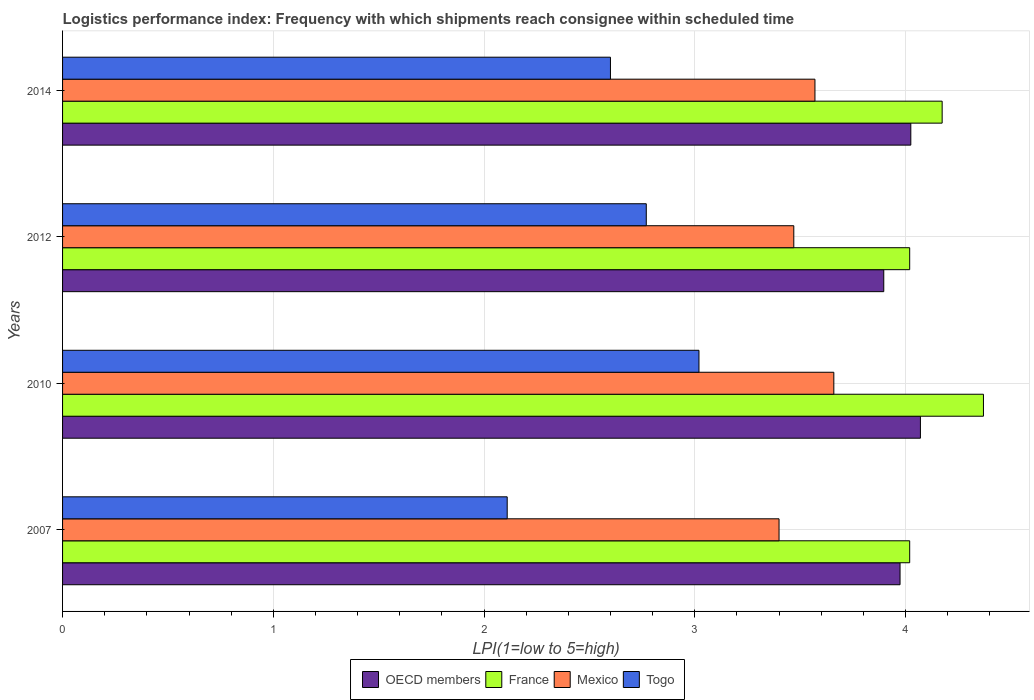How many groups of bars are there?
Your answer should be very brief. 4. Are the number of bars on each tick of the Y-axis equal?
Offer a very short reply. Yes. How many bars are there on the 3rd tick from the top?
Your answer should be very brief. 4. What is the label of the 3rd group of bars from the top?
Give a very brief answer. 2010. In how many cases, is the number of bars for a given year not equal to the number of legend labels?
Your answer should be compact. 0. What is the logistics performance index in France in 2007?
Keep it short and to the point. 4.02. Across all years, what is the maximum logistics performance index in OECD members?
Make the answer very short. 4.07. Across all years, what is the minimum logistics performance index in France?
Your response must be concise. 4.02. In which year was the logistics performance index in France maximum?
Offer a terse response. 2010. What is the total logistics performance index in Togo in the graph?
Offer a very short reply. 10.5. What is the difference between the logistics performance index in OECD members in 2010 and that in 2014?
Your answer should be compact. 0.05. What is the difference between the logistics performance index in France in 2014 and the logistics performance index in OECD members in 2007?
Your answer should be very brief. 0.2. What is the average logistics performance index in Mexico per year?
Offer a very short reply. 3.53. In the year 2012, what is the difference between the logistics performance index in OECD members and logistics performance index in France?
Keep it short and to the point. -0.12. In how many years, is the logistics performance index in Togo greater than 2 ?
Keep it short and to the point. 4. What is the ratio of the logistics performance index in Mexico in 2012 to that in 2014?
Your answer should be compact. 0.97. Is the logistics performance index in France in 2010 less than that in 2014?
Ensure brevity in your answer.  No. What is the difference between the highest and the second highest logistics performance index in Mexico?
Offer a very short reply. 0.09. What is the difference between the highest and the lowest logistics performance index in OECD members?
Give a very brief answer. 0.17. In how many years, is the logistics performance index in France greater than the average logistics performance index in France taken over all years?
Your response must be concise. 2. Is the sum of the logistics performance index in France in 2012 and 2014 greater than the maximum logistics performance index in Mexico across all years?
Keep it short and to the point. Yes. Is it the case that in every year, the sum of the logistics performance index in France and logistics performance index in Togo is greater than the sum of logistics performance index in Mexico and logistics performance index in OECD members?
Keep it short and to the point. No. What does the 2nd bar from the top in 2012 represents?
Keep it short and to the point. Mexico. What does the 3rd bar from the bottom in 2007 represents?
Offer a terse response. Mexico. Is it the case that in every year, the sum of the logistics performance index in OECD members and logistics performance index in France is greater than the logistics performance index in Mexico?
Make the answer very short. Yes. How many bars are there?
Give a very brief answer. 16. Are the values on the major ticks of X-axis written in scientific E-notation?
Your answer should be very brief. No. Where does the legend appear in the graph?
Your response must be concise. Bottom center. How many legend labels are there?
Your answer should be compact. 4. How are the legend labels stacked?
Provide a short and direct response. Horizontal. What is the title of the graph?
Offer a very short reply. Logistics performance index: Frequency with which shipments reach consignee within scheduled time. What is the label or title of the X-axis?
Make the answer very short. LPI(1=low to 5=high). What is the LPI(1=low to 5=high) in OECD members in 2007?
Make the answer very short. 3.97. What is the LPI(1=low to 5=high) of France in 2007?
Provide a short and direct response. 4.02. What is the LPI(1=low to 5=high) of Mexico in 2007?
Your answer should be compact. 3.4. What is the LPI(1=low to 5=high) in Togo in 2007?
Keep it short and to the point. 2.11. What is the LPI(1=low to 5=high) of OECD members in 2010?
Provide a short and direct response. 4.07. What is the LPI(1=low to 5=high) in France in 2010?
Your response must be concise. 4.37. What is the LPI(1=low to 5=high) of Mexico in 2010?
Give a very brief answer. 3.66. What is the LPI(1=low to 5=high) in Togo in 2010?
Provide a succinct answer. 3.02. What is the LPI(1=low to 5=high) in OECD members in 2012?
Ensure brevity in your answer.  3.9. What is the LPI(1=low to 5=high) in France in 2012?
Give a very brief answer. 4.02. What is the LPI(1=low to 5=high) in Mexico in 2012?
Make the answer very short. 3.47. What is the LPI(1=low to 5=high) in Togo in 2012?
Keep it short and to the point. 2.77. What is the LPI(1=low to 5=high) in OECD members in 2014?
Provide a short and direct response. 4.03. What is the LPI(1=low to 5=high) of France in 2014?
Your response must be concise. 4.17. What is the LPI(1=low to 5=high) of Mexico in 2014?
Give a very brief answer. 3.57. What is the LPI(1=low to 5=high) of Togo in 2014?
Your answer should be compact. 2.6. Across all years, what is the maximum LPI(1=low to 5=high) of OECD members?
Your answer should be very brief. 4.07. Across all years, what is the maximum LPI(1=low to 5=high) of France?
Give a very brief answer. 4.37. Across all years, what is the maximum LPI(1=low to 5=high) of Mexico?
Make the answer very short. 3.66. Across all years, what is the maximum LPI(1=low to 5=high) of Togo?
Offer a terse response. 3.02. Across all years, what is the minimum LPI(1=low to 5=high) in OECD members?
Offer a very short reply. 3.9. Across all years, what is the minimum LPI(1=low to 5=high) in France?
Give a very brief answer. 4.02. Across all years, what is the minimum LPI(1=low to 5=high) in Mexico?
Ensure brevity in your answer.  3.4. Across all years, what is the minimum LPI(1=low to 5=high) of Togo?
Give a very brief answer. 2.11. What is the total LPI(1=low to 5=high) of OECD members in the graph?
Provide a succinct answer. 15.97. What is the total LPI(1=low to 5=high) in France in the graph?
Provide a succinct answer. 16.58. What is the total LPI(1=low to 5=high) of Mexico in the graph?
Offer a very short reply. 14.1. What is the difference between the LPI(1=low to 5=high) of OECD members in 2007 and that in 2010?
Provide a succinct answer. -0.1. What is the difference between the LPI(1=low to 5=high) of France in 2007 and that in 2010?
Offer a terse response. -0.35. What is the difference between the LPI(1=low to 5=high) in Mexico in 2007 and that in 2010?
Your response must be concise. -0.26. What is the difference between the LPI(1=low to 5=high) of Togo in 2007 and that in 2010?
Make the answer very short. -0.91. What is the difference between the LPI(1=low to 5=high) in OECD members in 2007 and that in 2012?
Your response must be concise. 0.08. What is the difference between the LPI(1=low to 5=high) of France in 2007 and that in 2012?
Make the answer very short. 0. What is the difference between the LPI(1=low to 5=high) of Mexico in 2007 and that in 2012?
Your answer should be compact. -0.07. What is the difference between the LPI(1=low to 5=high) in Togo in 2007 and that in 2012?
Keep it short and to the point. -0.66. What is the difference between the LPI(1=low to 5=high) of OECD members in 2007 and that in 2014?
Provide a short and direct response. -0.05. What is the difference between the LPI(1=low to 5=high) in France in 2007 and that in 2014?
Offer a terse response. -0.15. What is the difference between the LPI(1=low to 5=high) of Mexico in 2007 and that in 2014?
Your answer should be compact. -0.17. What is the difference between the LPI(1=low to 5=high) in Togo in 2007 and that in 2014?
Give a very brief answer. -0.49. What is the difference between the LPI(1=low to 5=high) of OECD members in 2010 and that in 2012?
Your response must be concise. 0.17. What is the difference between the LPI(1=low to 5=high) of Mexico in 2010 and that in 2012?
Your answer should be very brief. 0.19. What is the difference between the LPI(1=low to 5=high) of Togo in 2010 and that in 2012?
Offer a very short reply. 0.25. What is the difference between the LPI(1=low to 5=high) in OECD members in 2010 and that in 2014?
Offer a very short reply. 0.05. What is the difference between the LPI(1=low to 5=high) of France in 2010 and that in 2014?
Your answer should be very brief. 0.2. What is the difference between the LPI(1=low to 5=high) of Mexico in 2010 and that in 2014?
Offer a terse response. 0.09. What is the difference between the LPI(1=low to 5=high) of Togo in 2010 and that in 2014?
Provide a succinct answer. 0.42. What is the difference between the LPI(1=low to 5=high) in OECD members in 2012 and that in 2014?
Make the answer very short. -0.13. What is the difference between the LPI(1=low to 5=high) in France in 2012 and that in 2014?
Give a very brief answer. -0.15. What is the difference between the LPI(1=low to 5=high) in Mexico in 2012 and that in 2014?
Keep it short and to the point. -0.1. What is the difference between the LPI(1=low to 5=high) in Togo in 2012 and that in 2014?
Make the answer very short. 0.17. What is the difference between the LPI(1=low to 5=high) in OECD members in 2007 and the LPI(1=low to 5=high) in France in 2010?
Offer a very short reply. -0.4. What is the difference between the LPI(1=low to 5=high) of OECD members in 2007 and the LPI(1=low to 5=high) of Mexico in 2010?
Ensure brevity in your answer.  0.31. What is the difference between the LPI(1=low to 5=high) of OECD members in 2007 and the LPI(1=low to 5=high) of Togo in 2010?
Your response must be concise. 0.95. What is the difference between the LPI(1=low to 5=high) in France in 2007 and the LPI(1=low to 5=high) in Mexico in 2010?
Give a very brief answer. 0.36. What is the difference between the LPI(1=low to 5=high) in France in 2007 and the LPI(1=low to 5=high) in Togo in 2010?
Offer a very short reply. 1. What is the difference between the LPI(1=low to 5=high) in Mexico in 2007 and the LPI(1=low to 5=high) in Togo in 2010?
Offer a very short reply. 0.38. What is the difference between the LPI(1=low to 5=high) in OECD members in 2007 and the LPI(1=low to 5=high) in France in 2012?
Your response must be concise. -0.05. What is the difference between the LPI(1=low to 5=high) of OECD members in 2007 and the LPI(1=low to 5=high) of Mexico in 2012?
Your answer should be very brief. 0.5. What is the difference between the LPI(1=low to 5=high) in OECD members in 2007 and the LPI(1=low to 5=high) in Togo in 2012?
Ensure brevity in your answer.  1.2. What is the difference between the LPI(1=low to 5=high) in France in 2007 and the LPI(1=low to 5=high) in Mexico in 2012?
Provide a short and direct response. 0.55. What is the difference between the LPI(1=low to 5=high) in Mexico in 2007 and the LPI(1=low to 5=high) in Togo in 2012?
Your response must be concise. 0.63. What is the difference between the LPI(1=low to 5=high) in OECD members in 2007 and the LPI(1=low to 5=high) in France in 2014?
Your answer should be compact. -0.2. What is the difference between the LPI(1=low to 5=high) of OECD members in 2007 and the LPI(1=low to 5=high) of Mexico in 2014?
Provide a short and direct response. 0.4. What is the difference between the LPI(1=low to 5=high) of OECD members in 2007 and the LPI(1=low to 5=high) of Togo in 2014?
Your answer should be compact. 1.37. What is the difference between the LPI(1=low to 5=high) in France in 2007 and the LPI(1=low to 5=high) in Mexico in 2014?
Give a very brief answer. 0.45. What is the difference between the LPI(1=low to 5=high) in France in 2007 and the LPI(1=low to 5=high) in Togo in 2014?
Offer a very short reply. 1.42. What is the difference between the LPI(1=low to 5=high) of Mexico in 2007 and the LPI(1=low to 5=high) of Togo in 2014?
Make the answer very short. 0.8. What is the difference between the LPI(1=low to 5=high) in OECD members in 2010 and the LPI(1=low to 5=high) in France in 2012?
Give a very brief answer. 0.05. What is the difference between the LPI(1=low to 5=high) in OECD members in 2010 and the LPI(1=low to 5=high) in Mexico in 2012?
Keep it short and to the point. 0.6. What is the difference between the LPI(1=low to 5=high) in OECD members in 2010 and the LPI(1=low to 5=high) in Togo in 2012?
Your answer should be compact. 1.3. What is the difference between the LPI(1=low to 5=high) of France in 2010 and the LPI(1=low to 5=high) of Mexico in 2012?
Offer a terse response. 0.9. What is the difference between the LPI(1=low to 5=high) of France in 2010 and the LPI(1=low to 5=high) of Togo in 2012?
Provide a succinct answer. 1.6. What is the difference between the LPI(1=low to 5=high) of Mexico in 2010 and the LPI(1=low to 5=high) of Togo in 2012?
Keep it short and to the point. 0.89. What is the difference between the LPI(1=low to 5=high) in OECD members in 2010 and the LPI(1=low to 5=high) in France in 2014?
Ensure brevity in your answer.  -0.1. What is the difference between the LPI(1=low to 5=high) of OECD members in 2010 and the LPI(1=low to 5=high) of Mexico in 2014?
Provide a short and direct response. 0.5. What is the difference between the LPI(1=low to 5=high) in OECD members in 2010 and the LPI(1=low to 5=high) in Togo in 2014?
Provide a succinct answer. 1.47. What is the difference between the LPI(1=low to 5=high) of France in 2010 and the LPI(1=low to 5=high) of Mexico in 2014?
Your response must be concise. 0.8. What is the difference between the LPI(1=low to 5=high) of France in 2010 and the LPI(1=low to 5=high) of Togo in 2014?
Keep it short and to the point. 1.77. What is the difference between the LPI(1=low to 5=high) of Mexico in 2010 and the LPI(1=low to 5=high) of Togo in 2014?
Provide a succinct answer. 1.06. What is the difference between the LPI(1=low to 5=high) in OECD members in 2012 and the LPI(1=low to 5=high) in France in 2014?
Your answer should be compact. -0.28. What is the difference between the LPI(1=low to 5=high) of OECD members in 2012 and the LPI(1=low to 5=high) of Mexico in 2014?
Your response must be concise. 0.33. What is the difference between the LPI(1=low to 5=high) of OECD members in 2012 and the LPI(1=low to 5=high) of Togo in 2014?
Offer a terse response. 1.3. What is the difference between the LPI(1=low to 5=high) of France in 2012 and the LPI(1=low to 5=high) of Mexico in 2014?
Provide a succinct answer. 0.45. What is the difference between the LPI(1=low to 5=high) of France in 2012 and the LPI(1=low to 5=high) of Togo in 2014?
Provide a short and direct response. 1.42. What is the difference between the LPI(1=low to 5=high) of Mexico in 2012 and the LPI(1=low to 5=high) of Togo in 2014?
Provide a short and direct response. 0.87. What is the average LPI(1=low to 5=high) in OECD members per year?
Your response must be concise. 3.99. What is the average LPI(1=low to 5=high) in France per year?
Offer a very short reply. 4.15. What is the average LPI(1=low to 5=high) in Mexico per year?
Offer a terse response. 3.53. What is the average LPI(1=low to 5=high) of Togo per year?
Your answer should be very brief. 2.62. In the year 2007, what is the difference between the LPI(1=low to 5=high) of OECD members and LPI(1=low to 5=high) of France?
Ensure brevity in your answer.  -0.05. In the year 2007, what is the difference between the LPI(1=low to 5=high) in OECD members and LPI(1=low to 5=high) in Mexico?
Offer a very short reply. 0.57. In the year 2007, what is the difference between the LPI(1=low to 5=high) in OECD members and LPI(1=low to 5=high) in Togo?
Provide a short and direct response. 1.86. In the year 2007, what is the difference between the LPI(1=low to 5=high) in France and LPI(1=low to 5=high) in Mexico?
Give a very brief answer. 0.62. In the year 2007, what is the difference between the LPI(1=low to 5=high) in France and LPI(1=low to 5=high) in Togo?
Offer a terse response. 1.91. In the year 2007, what is the difference between the LPI(1=low to 5=high) of Mexico and LPI(1=low to 5=high) of Togo?
Your response must be concise. 1.29. In the year 2010, what is the difference between the LPI(1=low to 5=high) of OECD members and LPI(1=low to 5=high) of France?
Your answer should be compact. -0.3. In the year 2010, what is the difference between the LPI(1=low to 5=high) of OECD members and LPI(1=low to 5=high) of Mexico?
Give a very brief answer. 0.41. In the year 2010, what is the difference between the LPI(1=low to 5=high) in OECD members and LPI(1=low to 5=high) in Togo?
Give a very brief answer. 1.05. In the year 2010, what is the difference between the LPI(1=low to 5=high) in France and LPI(1=low to 5=high) in Mexico?
Offer a very short reply. 0.71. In the year 2010, what is the difference between the LPI(1=low to 5=high) of France and LPI(1=low to 5=high) of Togo?
Provide a succinct answer. 1.35. In the year 2010, what is the difference between the LPI(1=low to 5=high) of Mexico and LPI(1=low to 5=high) of Togo?
Offer a terse response. 0.64. In the year 2012, what is the difference between the LPI(1=low to 5=high) of OECD members and LPI(1=low to 5=high) of France?
Your answer should be compact. -0.12. In the year 2012, what is the difference between the LPI(1=low to 5=high) of OECD members and LPI(1=low to 5=high) of Mexico?
Ensure brevity in your answer.  0.43. In the year 2012, what is the difference between the LPI(1=low to 5=high) in OECD members and LPI(1=low to 5=high) in Togo?
Make the answer very short. 1.13. In the year 2012, what is the difference between the LPI(1=low to 5=high) of France and LPI(1=low to 5=high) of Mexico?
Make the answer very short. 0.55. In the year 2012, what is the difference between the LPI(1=low to 5=high) in Mexico and LPI(1=low to 5=high) in Togo?
Provide a succinct answer. 0.7. In the year 2014, what is the difference between the LPI(1=low to 5=high) in OECD members and LPI(1=low to 5=high) in France?
Ensure brevity in your answer.  -0.15. In the year 2014, what is the difference between the LPI(1=low to 5=high) in OECD members and LPI(1=low to 5=high) in Mexico?
Offer a very short reply. 0.45. In the year 2014, what is the difference between the LPI(1=low to 5=high) of OECD members and LPI(1=low to 5=high) of Togo?
Your response must be concise. 1.43. In the year 2014, what is the difference between the LPI(1=low to 5=high) of France and LPI(1=low to 5=high) of Mexico?
Make the answer very short. 0.6. In the year 2014, what is the difference between the LPI(1=low to 5=high) of France and LPI(1=low to 5=high) of Togo?
Keep it short and to the point. 1.57. In the year 2014, what is the difference between the LPI(1=low to 5=high) of Mexico and LPI(1=low to 5=high) of Togo?
Make the answer very short. 0.97. What is the ratio of the LPI(1=low to 5=high) in OECD members in 2007 to that in 2010?
Ensure brevity in your answer.  0.98. What is the ratio of the LPI(1=low to 5=high) of France in 2007 to that in 2010?
Offer a terse response. 0.92. What is the ratio of the LPI(1=low to 5=high) in Mexico in 2007 to that in 2010?
Ensure brevity in your answer.  0.93. What is the ratio of the LPI(1=low to 5=high) of Togo in 2007 to that in 2010?
Provide a succinct answer. 0.7. What is the ratio of the LPI(1=low to 5=high) in OECD members in 2007 to that in 2012?
Your answer should be compact. 1.02. What is the ratio of the LPI(1=low to 5=high) of France in 2007 to that in 2012?
Provide a short and direct response. 1. What is the ratio of the LPI(1=low to 5=high) in Mexico in 2007 to that in 2012?
Your answer should be very brief. 0.98. What is the ratio of the LPI(1=low to 5=high) of Togo in 2007 to that in 2012?
Ensure brevity in your answer.  0.76. What is the ratio of the LPI(1=low to 5=high) in OECD members in 2007 to that in 2014?
Your response must be concise. 0.99. What is the ratio of the LPI(1=low to 5=high) of France in 2007 to that in 2014?
Make the answer very short. 0.96. What is the ratio of the LPI(1=low to 5=high) in Mexico in 2007 to that in 2014?
Offer a very short reply. 0.95. What is the ratio of the LPI(1=low to 5=high) in Togo in 2007 to that in 2014?
Make the answer very short. 0.81. What is the ratio of the LPI(1=low to 5=high) in OECD members in 2010 to that in 2012?
Provide a short and direct response. 1.04. What is the ratio of the LPI(1=low to 5=high) in France in 2010 to that in 2012?
Your answer should be very brief. 1.09. What is the ratio of the LPI(1=low to 5=high) in Mexico in 2010 to that in 2012?
Provide a succinct answer. 1.05. What is the ratio of the LPI(1=low to 5=high) in Togo in 2010 to that in 2012?
Offer a very short reply. 1.09. What is the ratio of the LPI(1=low to 5=high) of OECD members in 2010 to that in 2014?
Make the answer very short. 1.01. What is the ratio of the LPI(1=low to 5=high) in France in 2010 to that in 2014?
Make the answer very short. 1.05. What is the ratio of the LPI(1=low to 5=high) in Mexico in 2010 to that in 2014?
Provide a short and direct response. 1.03. What is the ratio of the LPI(1=low to 5=high) in Togo in 2010 to that in 2014?
Give a very brief answer. 1.16. What is the ratio of the LPI(1=low to 5=high) of OECD members in 2012 to that in 2014?
Give a very brief answer. 0.97. What is the ratio of the LPI(1=low to 5=high) in France in 2012 to that in 2014?
Keep it short and to the point. 0.96. What is the ratio of the LPI(1=low to 5=high) in Mexico in 2012 to that in 2014?
Offer a very short reply. 0.97. What is the ratio of the LPI(1=low to 5=high) of Togo in 2012 to that in 2014?
Ensure brevity in your answer.  1.07. What is the difference between the highest and the second highest LPI(1=low to 5=high) in OECD members?
Provide a short and direct response. 0.05. What is the difference between the highest and the second highest LPI(1=low to 5=high) in France?
Your response must be concise. 0.2. What is the difference between the highest and the second highest LPI(1=low to 5=high) in Mexico?
Provide a short and direct response. 0.09. What is the difference between the highest and the second highest LPI(1=low to 5=high) of Togo?
Offer a very short reply. 0.25. What is the difference between the highest and the lowest LPI(1=low to 5=high) in OECD members?
Give a very brief answer. 0.17. What is the difference between the highest and the lowest LPI(1=low to 5=high) in Mexico?
Provide a succinct answer. 0.26. What is the difference between the highest and the lowest LPI(1=low to 5=high) in Togo?
Make the answer very short. 0.91. 